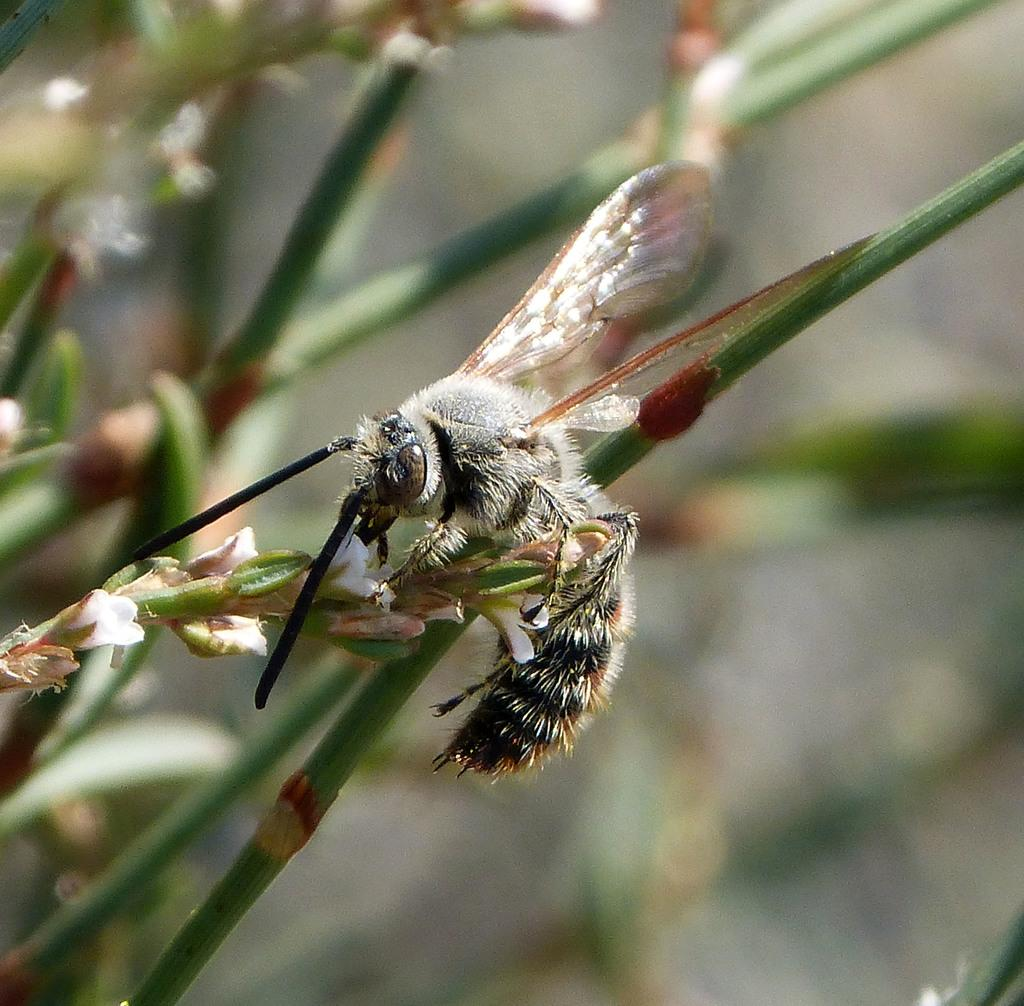What type of living organisms can be seen in the image? There are plants with flowers in the image. Can you describe any other living organisms present in the image? Yes, there is an insect on one of the plants. What type of button can be seen floating in the bubble in the image? There is no button or bubble present in the image; it features plants with flowers and an insect. 